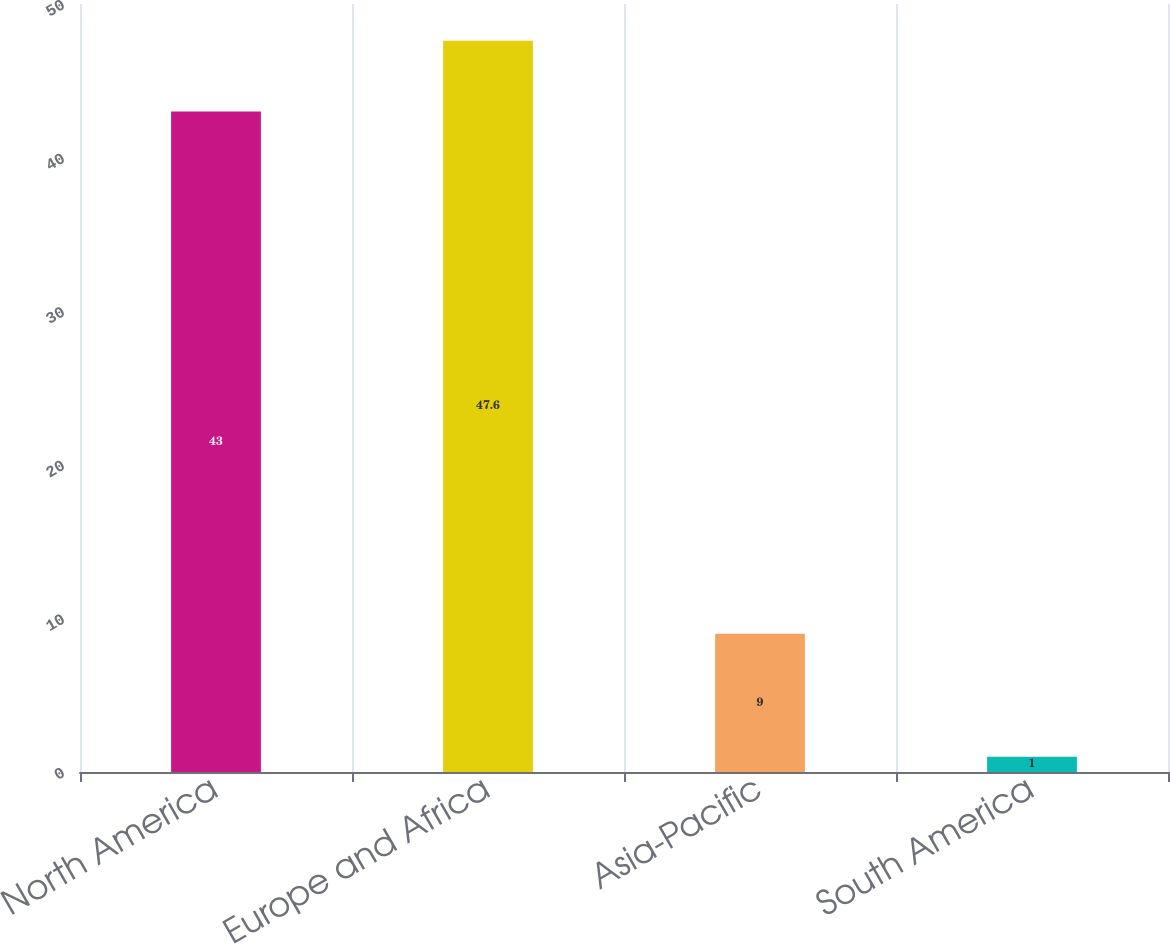Convert chart to OTSL. <chart><loc_0><loc_0><loc_500><loc_500><bar_chart><fcel>North America<fcel>Europe and Africa<fcel>Asia-Pacific<fcel>South America<nl><fcel>43<fcel>47.6<fcel>9<fcel>1<nl></chart> 